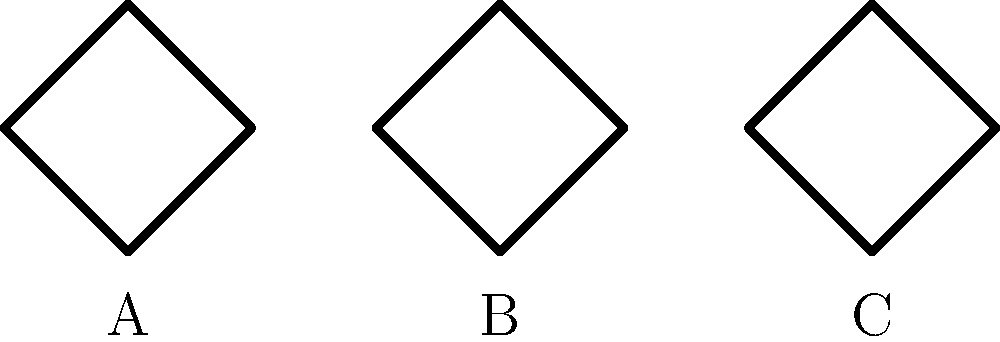Which of the Celtic knot patterns shown above represents the concept of eternity and interconnectedness in Celtic culture? To answer this question, let's analyze each knot pattern:

1. Pattern A: This is a simple four-cornered knot, also known as a "quaternary knot." It represents the four seasons or four elements in Celtic symbolism.

2. Pattern B: This is the "Triquetra" or "Trinity Knot." It consists of three interlocked loops, symbolizing the interconnectedness of mind, body, and spirit, or the Christian Holy Trinity in later Celtic Christian art.

3. Pattern C: This is the "Eternity Knot" or "Endless Knot." It is characterized by its continuous looping pattern with no beginning or end.

The concept of eternity and interconnectedness in Celtic culture is best represented by the Eternity Knot (Pattern C). Its endless, unbroken design symbolizes the eternal nature of life, love, and faith in Celtic belief systems. The continuous loop also represents the interconnectedness of all things in the universe, a fundamental concept in Celtic spirituality.

Therefore, the correct answer is Pattern C, the Eternity Knot.
Answer: C 